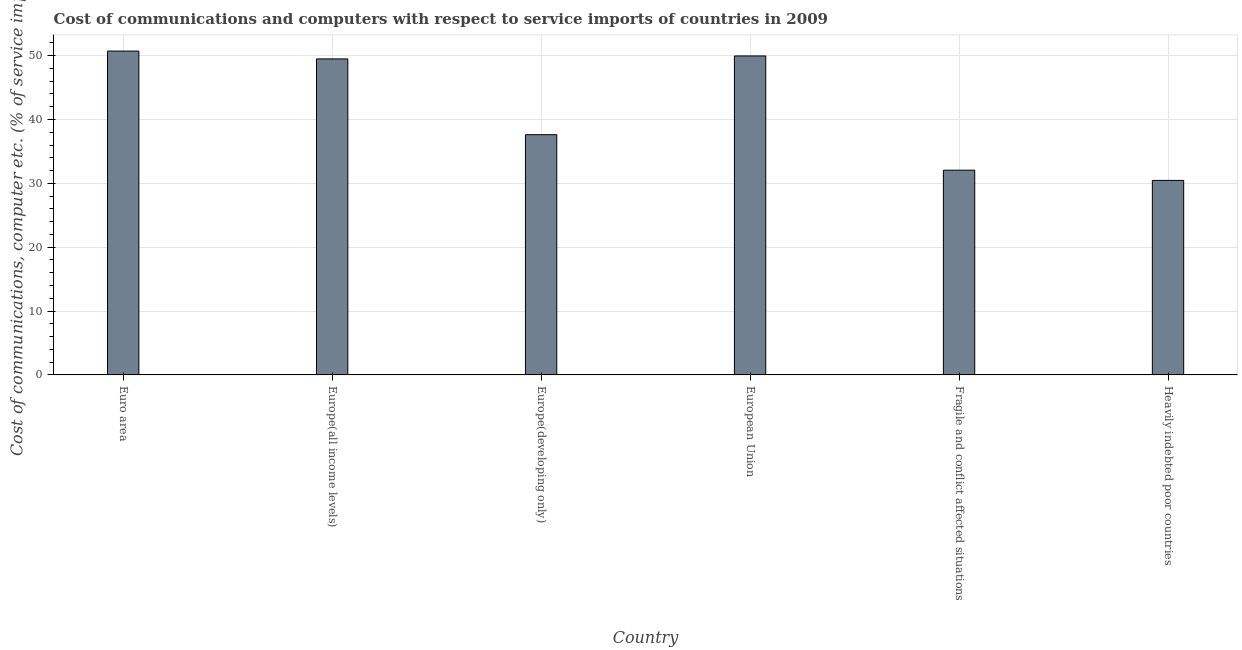Does the graph contain any zero values?
Your answer should be very brief. No. Does the graph contain grids?
Provide a succinct answer. Yes. What is the title of the graph?
Provide a short and direct response. Cost of communications and computers with respect to service imports of countries in 2009. What is the label or title of the X-axis?
Your answer should be very brief. Country. What is the label or title of the Y-axis?
Your response must be concise. Cost of communications, computer etc. (% of service imports). What is the cost of communications and computer in Europe(developing only)?
Your answer should be compact. 37.61. Across all countries, what is the maximum cost of communications and computer?
Your response must be concise. 50.71. Across all countries, what is the minimum cost of communications and computer?
Ensure brevity in your answer.  30.46. In which country was the cost of communications and computer minimum?
Ensure brevity in your answer.  Heavily indebted poor countries. What is the sum of the cost of communications and computer?
Offer a terse response. 250.26. What is the difference between the cost of communications and computer in European Union and Fragile and conflict affected situations?
Give a very brief answer. 17.89. What is the average cost of communications and computer per country?
Your answer should be very brief. 41.71. What is the median cost of communications and computer?
Your answer should be compact. 43.55. In how many countries, is the cost of communications and computer greater than 6 %?
Keep it short and to the point. 6. What is the ratio of the cost of communications and computer in Europe(all income levels) to that in Europe(developing only)?
Make the answer very short. 1.32. Is the cost of communications and computer in Europe(all income levels) less than that in Europe(developing only)?
Provide a short and direct response. No. What is the difference between the highest and the second highest cost of communications and computer?
Your answer should be very brief. 0.76. What is the difference between the highest and the lowest cost of communications and computer?
Give a very brief answer. 20.25. How many bars are there?
Your answer should be compact. 6. Are all the bars in the graph horizontal?
Offer a terse response. No. What is the Cost of communications, computer etc. (% of service imports) in Euro area?
Provide a succinct answer. 50.71. What is the Cost of communications, computer etc. (% of service imports) of Europe(all income levels)?
Offer a very short reply. 49.48. What is the Cost of communications, computer etc. (% of service imports) in Europe(developing only)?
Make the answer very short. 37.61. What is the Cost of communications, computer etc. (% of service imports) in European Union?
Offer a terse response. 49.95. What is the Cost of communications, computer etc. (% of service imports) in Fragile and conflict affected situations?
Provide a short and direct response. 32.06. What is the Cost of communications, computer etc. (% of service imports) of Heavily indebted poor countries?
Offer a terse response. 30.46. What is the difference between the Cost of communications, computer etc. (% of service imports) in Euro area and Europe(all income levels)?
Provide a succinct answer. 1.23. What is the difference between the Cost of communications, computer etc. (% of service imports) in Euro area and Europe(developing only)?
Give a very brief answer. 13.09. What is the difference between the Cost of communications, computer etc. (% of service imports) in Euro area and European Union?
Your answer should be very brief. 0.76. What is the difference between the Cost of communications, computer etc. (% of service imports) in Euro area and Fragile and conflict affected situations?
Offer a terse response. 18.65. What is the difference between the Cost of communications, computer etc. (% of service imports) in Euro area and Heavily indebted poor countries?
Give a very brief answer. 20.25. What is the difference between the Cost of communications, computer etc. (% of service imports) in Europe(all income levels) and Europe(developing only)?
Offer a terse response. 11.87. What is the difference between the Cost of communications, computer etc. (% of service imports) in Europe(all income levels) and European Union?
Ensure brevity in your answer.  -0.46. What is the difference between the Cost of communications, computer etc. (% of service imports) in Europe(all income levels) and Fragile and conflict affected situations?
Your response must be concise. 17.43. What is the difference between the Cost of communications, computer etc. (% of service imports) in Europe(all income levels) and Heavily indebted poor countries?
Provide a succinct answer. 19.02. What is the difference between the Cost of communications, computer etc. (% of service imports) in Europe(developing only) and European Union?
Make the answer very short. -12.33. What is the difference between the Cost of communications, computer etc. (% of service imports) in Europe(developing only) and Fragile and conflict affected situations?
Your answer should be compact. 5.56. What is the difference between the Cost of communications, computer etc. (% of service imports) in Europe(developing only) and Heavily indebted poor countries?
Provide a succinct answer. 7.16. What is the difference between the Cost of communications, computer etc. (% of service imports) in European Union and Fragile and conflict affected situations?
Make the answer very short. 17.89. What is the difference between the Cost of communications, computer etc. (% of service imports) in European Union and Heavily indebted poor countries?
Ensure brevity in your answer.  19.49. What is the difference between the Cost of communications, computer etc. (% of service imports) in Fragile and conflict affected situations and Heavily indebted poor countries?
Give a very brief answer. 1.6. What is the ratio of the Cost of communications, computer etc. (% of service imports) in Euro area to that in Europe(all income levels)?
Keep it short and to the point. 1.02. What is the ratio of the Cost of communications, computer etc. (% of service imports) in Euro area to that in Europe(developing only)?
Give a very brief answer. 1.35. What is the ratio of the Cost of communications, computer etc. (% of service imports) in Euro area to that in Fragile and conflict affected situations?
Keep it short and to the point. 1.58. What is the ratio of the Cost of communications, computer etc. (% of service imports) in Euro area to that in Heavily indebted poor countries?
Provide a short and direct response. 1.67. What is the ratio of the Cost of communications, computer etc. (% of service imports) in Europe(all income levels) to that in Europe(developing only)?
Give a very brief answer. 1.32. What is the ratio of the Cost of communications, computer etc. (% of service imports) in Europe(all income levels) to that in Fragile and conflict affected situations?
Offer a very short reply. 1.54. What is the ratio of the Cost of communications, computer etc. (% of service imports) in Europe(all income levels) to that in Heavily indebted poor countries?
Offer a terse response. 1.62. What is the ratio of the Cost of communications, computer etc. (% of service imports) in Europe(developing only) to that in European Union?
Give a very brief answer. 0.75. What is the ratio of the Cost of communications, computer etc. (% of service imports) in Europe(developing only) to that in Fragile and conflict affected situations?
Provide a short and direct response. 1.17. What is the ratio of the Cost of communications, computer etc. (% of service imports) in Europe(developing only) to that in Heavily indebted poor countries?
Your answer should be very brief. 1.24. What is the ratio of the Cost of communications, computer etc. (% of service imports) in European Union to that in Fragile and conflict affected situations?
Your answer should be very brief. 1.56. What is the ratio of the Cost of communications, computer etc. (% of service imports) in European Union to that in Heavily indebted poor countries?
Your response must be concise. 1.64. What is the ratio of the Cost of communications, computer etc. (% of service imports) in Fragile and conflict affected situations to that in Heavily indebted poor countries?
Ensure brevity in your answer.  1.05. 